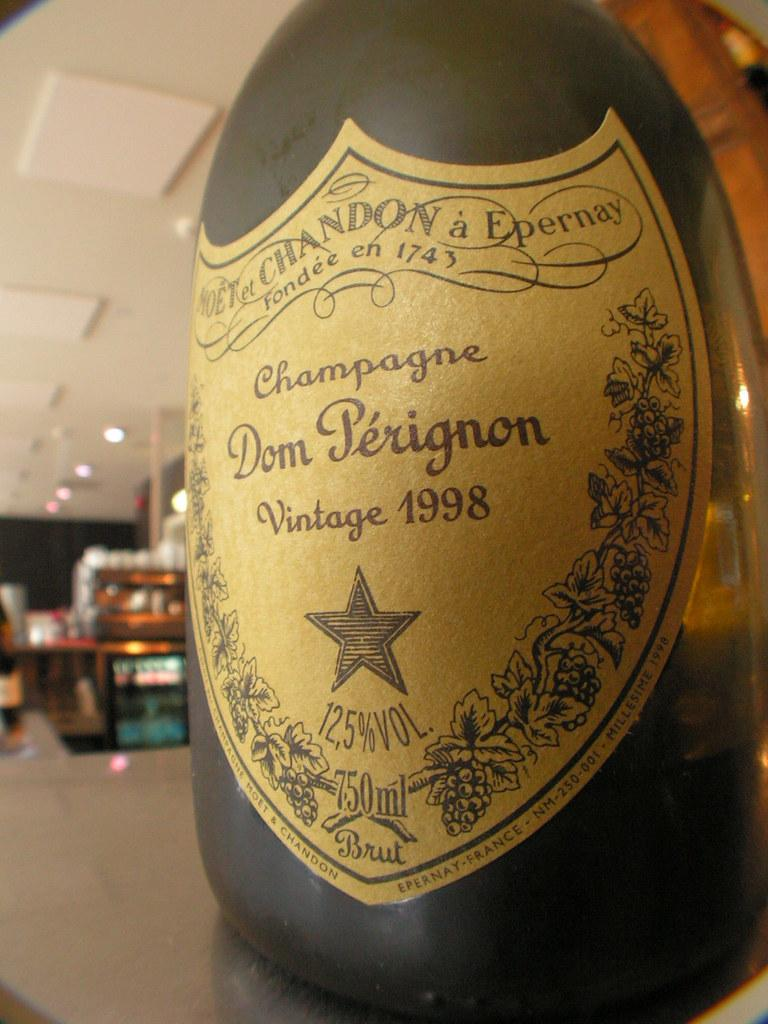Provide a one-sentence caption for the provided image. A 1998 bottle of Dom Perignon Champagne atop of a counter. 